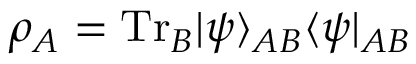Convert formula to latex. <formula><loc_0><loc_0><loc_500><loc_500>\rho _ { A } = T r _ { B } | \psi \rangle _ { A B } \langle \psi | _ { A B }</formula> 